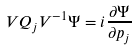<formula> <loc_0><loc_0><loc_500><loc_500>V Q _ { j } V ^ { - 1 } \Psi = i \frac { \partial \Psi } { \partial p _ { j } }</formula> 